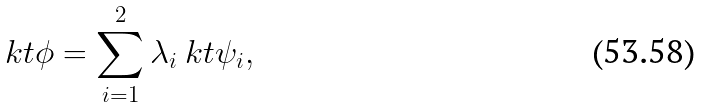Convert formula to latex. <formula><loc_0><loc_0><loc_500><loc_500>\ k t { \phi } = \sum _ { i = 1 } ^ { 2 } \lambda _ { i } \ k t { \psi _ { i } } ,</formula> 